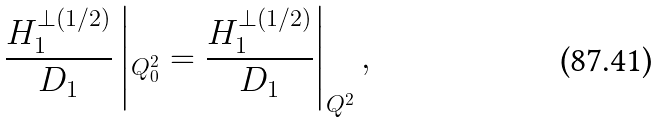<formula> <loc_0><loc_0><loc_500><loc_500>\frac { H _ { 1 } ^ { \perp ( 1 / 2 ) } } { D _ { 1 } } \left | _ { Q _ { 0 } ^ { 2 } } = \frac { H _ { 1 } ^ { \perp ( 1 / 2 ) } } { D _ { 1 } } \right | _ { Q ^ { 2 } } ,</formula> 